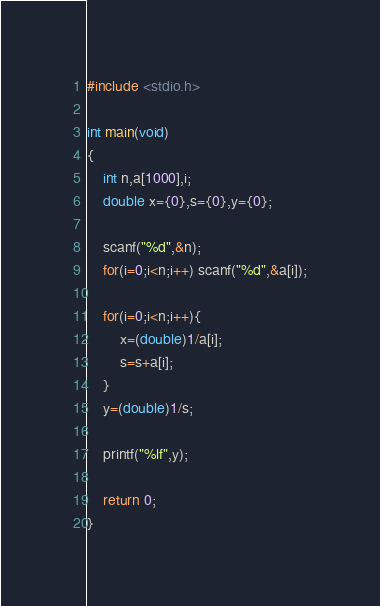Convert code to text. <code><loc_0><loc_0><loc_500><loc_500><_C_>#include <stdio.h>
 
int main(void)
{
    int n,a[1000],i;
    double x={0},s={0},y={0};
       
    scanf("%d",&n);
    for(i=0;i<n;i++) scanf("%d",&a[i]);
  
    for(i=0;i<n;i++){
        x=(double)1/a[i];
        s=s+a[i];
    }
    y=(double)1/s;
  
    printf("%lf",y);
  
    return 0;
}  </code> 